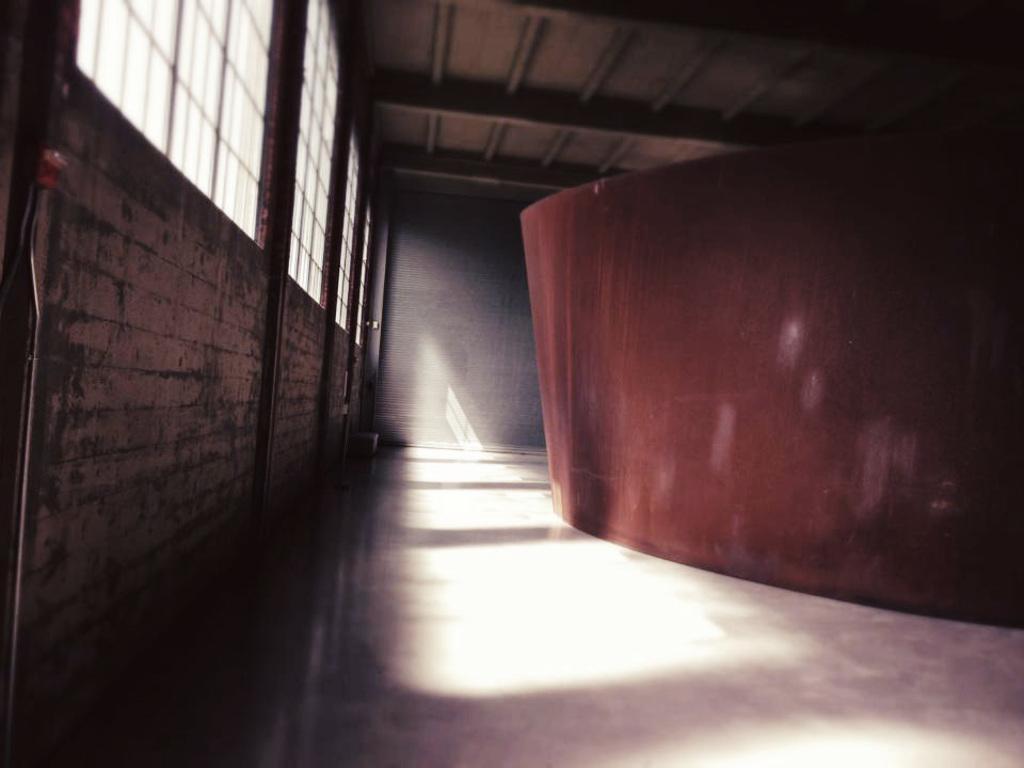Describe this image in one or two sentences. In this image I see the floor and I see the red color thing over here and I see the wall and I see the windows and I see the ceiling. 